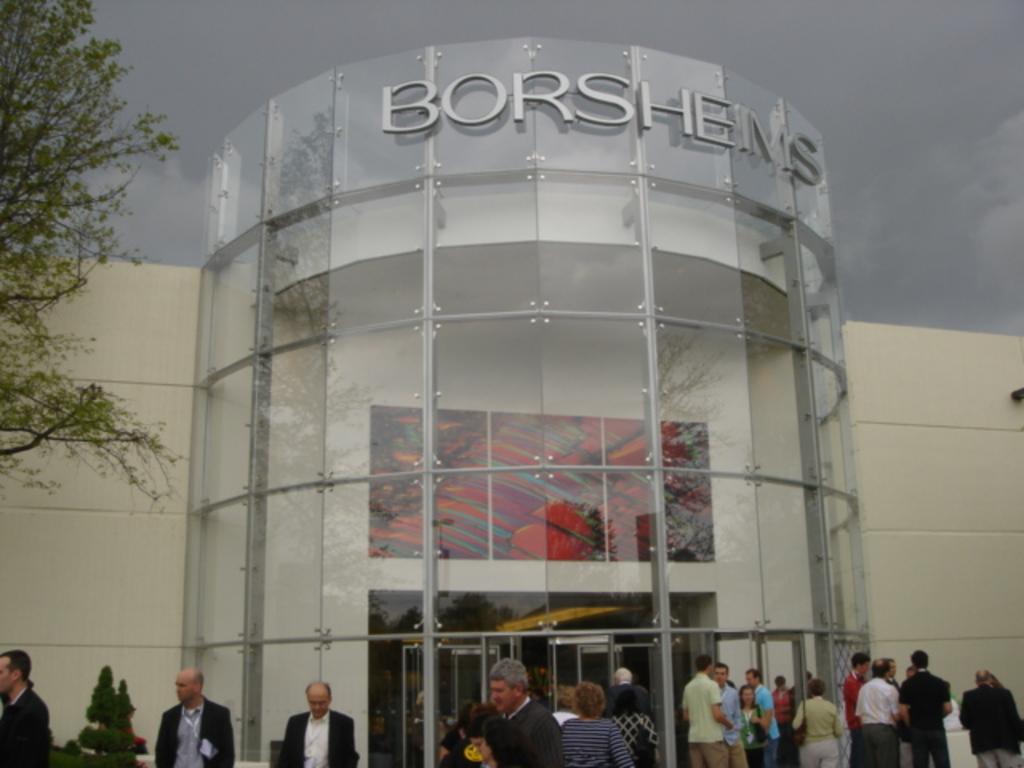Please provide a concise description of this image. In this image I can see the group of people with different color dresses. In-front of these people I can see the tree, building and the cloudy sky. 